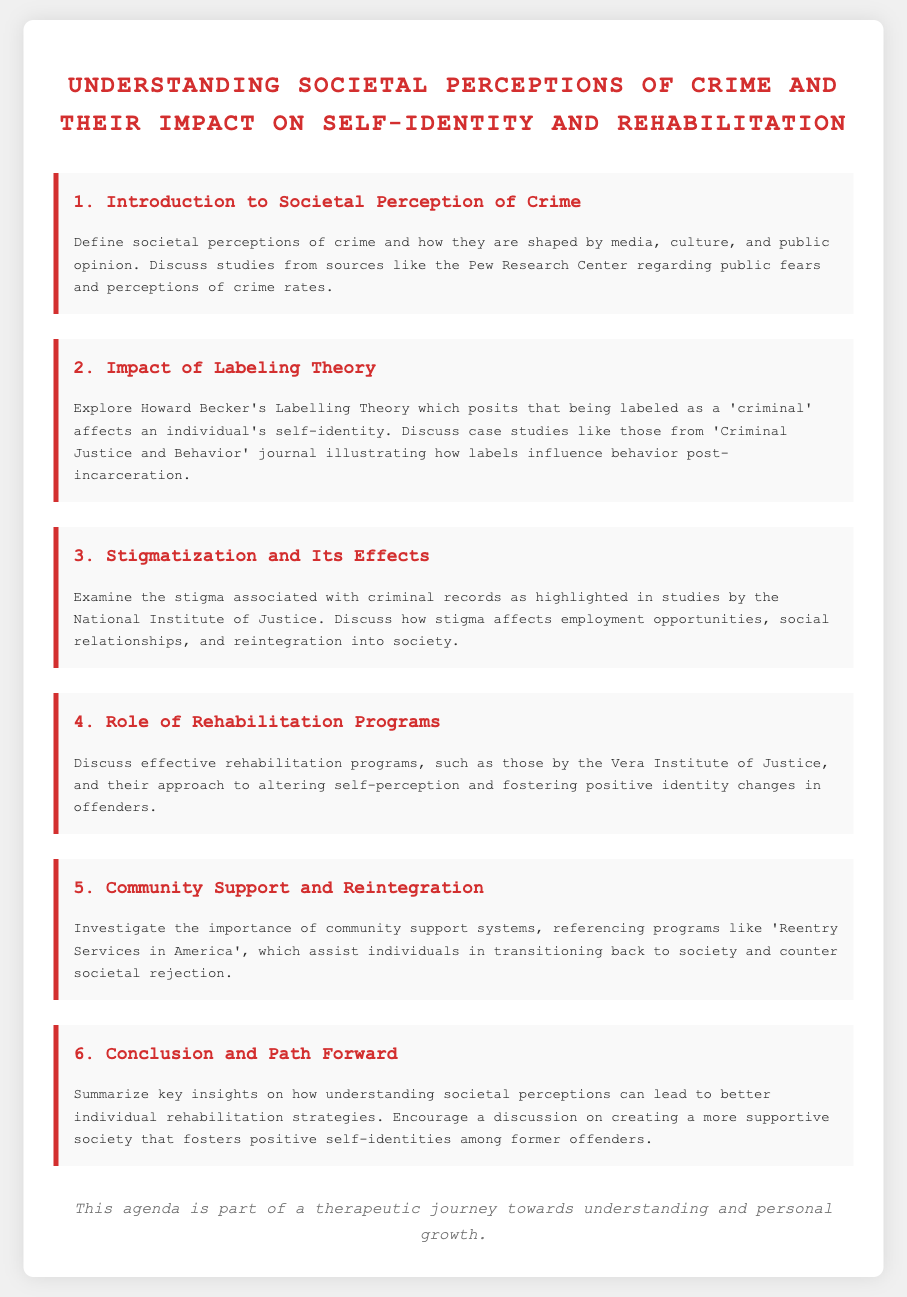What is the title of the document? The title is presented prominently at the top of the document, indicating its main topic.
Answer: Understanding Societal Perceptions of Crime and Their Impact on Self-Identity and Rehabilitation Who is the author of the studies mentioned in the document? The document references several studies, including those from the Pew Research Center, which highlights their credibility.
Answer: Pew Research Center What theory does the document discuss in relation to labeling? The agenda item 2 specifically mentions a well-known theory that deals with the effects of being labeled as a criminal.
Answer: Labelling Theory What organization is mentioned in relation to rehabilitation programs? The document references a specific institute known for its work on rehabilitation for offenders.
Answer: Vera Institute of Justice How many agenda items are listed in the document? By counting the sections, the total number of different discussion points can be easily determined.
Answer: Six What is the main effect of stigmatization discussed in the document? The document highlights a prominent aspect of how criminal records affect individuals in society.
Answer: Employment opportunities What is emphasized as important for reintegration into society? The agenda item 5 outlines a crucial component necessary for successful reintegration after incarceration.
Answer: Community support systems What is the document's purpose regarding societal perceptions? The last section of the document aims to summarize the insights gained in the discussion about societal perceptions.
Answer: Better individual rehabilitation strategies 